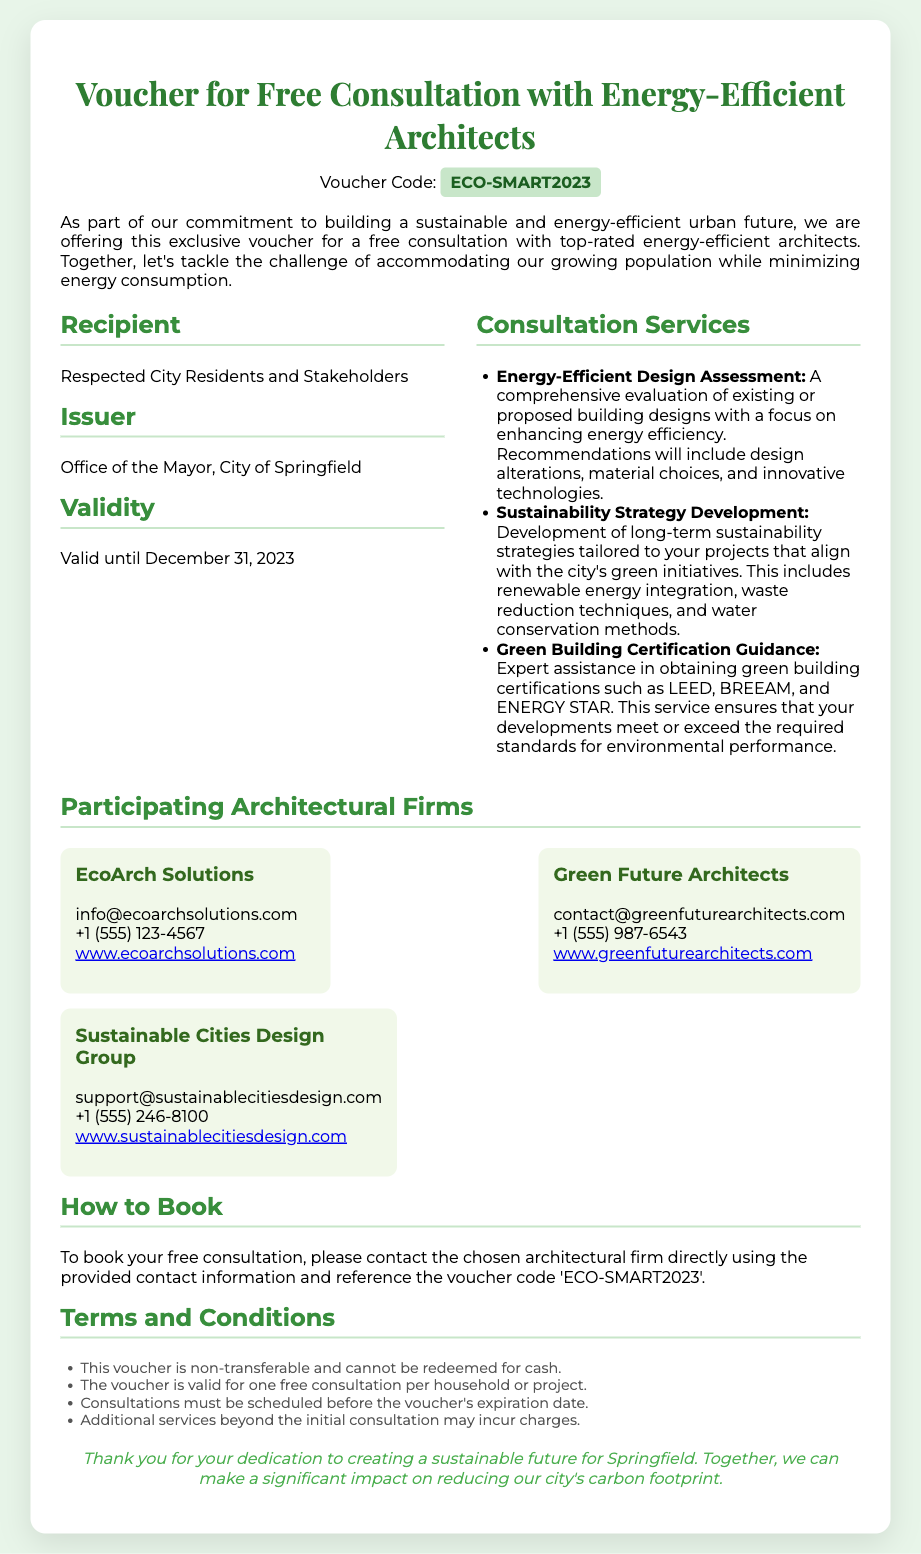What is the voucher code? The voucher code is explicitly stated in the document under the header section.
Answer: ECO-SMART2023 Who is the issuer of the voucher? The issuer of the voucher is mentioned in the details section.
Answer: Office of the Mayor, City of Springfield What is the validity period of the voucher? The validity is noted in the details portion of the document.
Answer: Valid until December 31, 2023 What type of service does the consultation provide? The types of consultation services are listed in detail under consultation services.
Answer: Energy-Efficient Design Assessment, Sustainability Strategy Development, Green Building Certification Guidance Which architectural firm has the email "support@sustainablecitiesdesign.com"? The email is associated with a specific architectural firm mentioned in the participating architectural firms section.
Answer: Sustainable Cities Design Group What must be referenced when booking the consultation? The booking instructions include a specific reference requirement explained in the document.
Answer: ECO-SMART2023 Is this voucher transferable? The terms and conditions outline the characteristics of the voucher's use.
Answer: No How many consultations are allowed per household? The terms clarify a limit on how many consultations can be redeemed per household.
Answer: One 